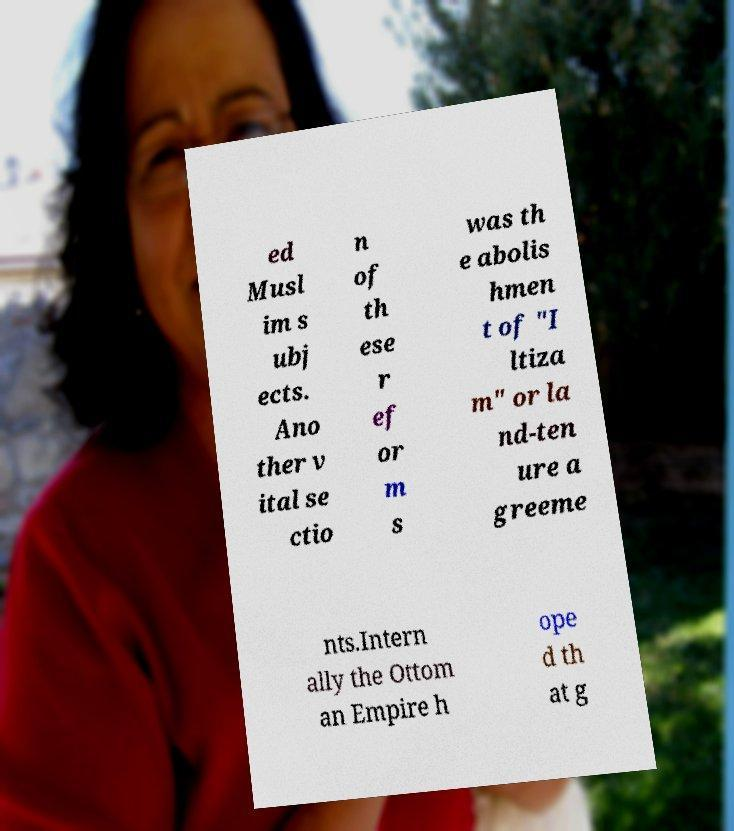For documentation purposes, I need the text within this image transcribed. Could you provide that? ed Musl im s ubj ects. Ano ther v ital se ctio n of th ese r ef or m s was th e abolis hmen t of "I ltiza m" or la nd-ten ure a greeme nts.Intern ally the Ottom an Empire h ope d th at g 